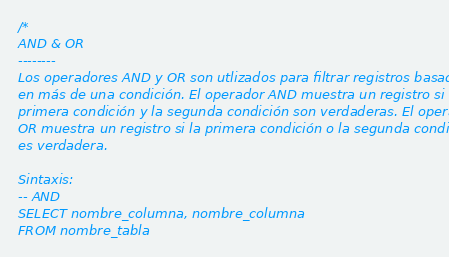Convert code to text. <code><loc_0><loc_0><loc_500><loc_500><_SQL_>/*
AND & OR
--------
Los operadores AND y OR son utlizados para filtrar registros basados
en más de una condición. El operador AND muestra un registro si la
primera condición y la segunda condición son verdaderas. El operador
OR muestra un registro si la primera condición o la segunda condición
es verdadera.

Sintaxis:
-- AND
SELECT nombre_columna, nombre_columna
FROM nombre_tabla</code> 